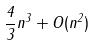<formula> <loc_0><loc_0><loc_500><loc_500>\frac { 4 } { 3 } n ^ { 3 } + O ( n ^ { 2 } )</formula> 